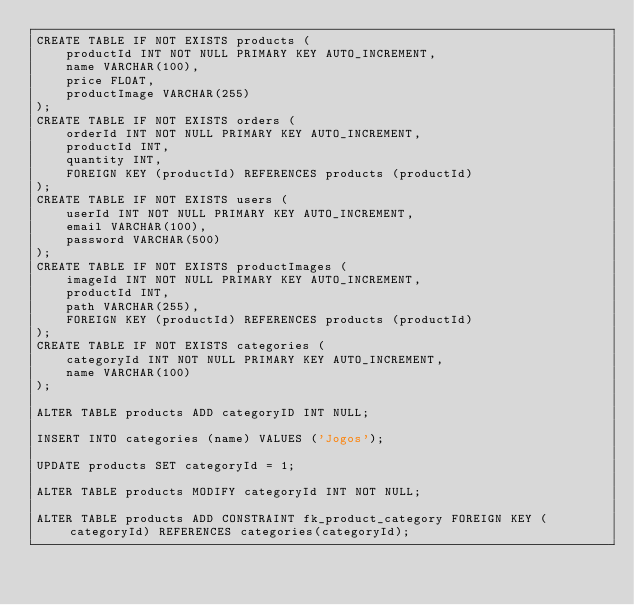<code> <loc_0><loc_0><loc_500><loc_500><_SQL_>CREATE TABLE IF NOT EXISTS products (
    productId INT NOT NULL PRIMARY KEY AUTO_INCREMENT,
    name VARCHAR(100),
    price FLOAT,
    productImage VARCHAR(255)
);
CREATE TABLE IF NOT EXISTS orders (
    orderId INT NOT NULL PRIMARY KEY AUTO_INCREMENT,
    productId INT,
    quantity INT,
    FOREIGN KEY (productId) REFERENCES products (productId)
);
CREATE TABLE IF NOT EXISTS users (
    userId INT NOT NULL PRIMARY KEY AUTO_INCREMENT,
    email VARCHAR(100),
    password VARCHAR(500)
);
CREATE TABLE IF NOT EXISTS productImages (
    imageId INT NOT NULL PRIMARY KEY AUTO_INCREMENT,
    productId INT,
    path VARCHAR(255),
    FOREIGN KEY (productId) REFERENCES products (productId)
);
CREATE TABLE IF NOT EXISTS categories (
    categoryId INT NOT NULL PRIMARY KEY AUTO_INCREMENT,
    name VARCHAR(100)
);

ALTER TABLE products ADD categoryID INT NULL;

INSERT INTO categories (name) VALUES ('Jogos');

UPDATE products SET categoryId = 1;

ALTER TABLE products MODIFY categoryId INT NOT NULL;

ALTER TABLE products ADD CONSTRAINT fk_product_category FOREIGN KEY (categoryId) REFERENCES categories(categoryId);</code> 